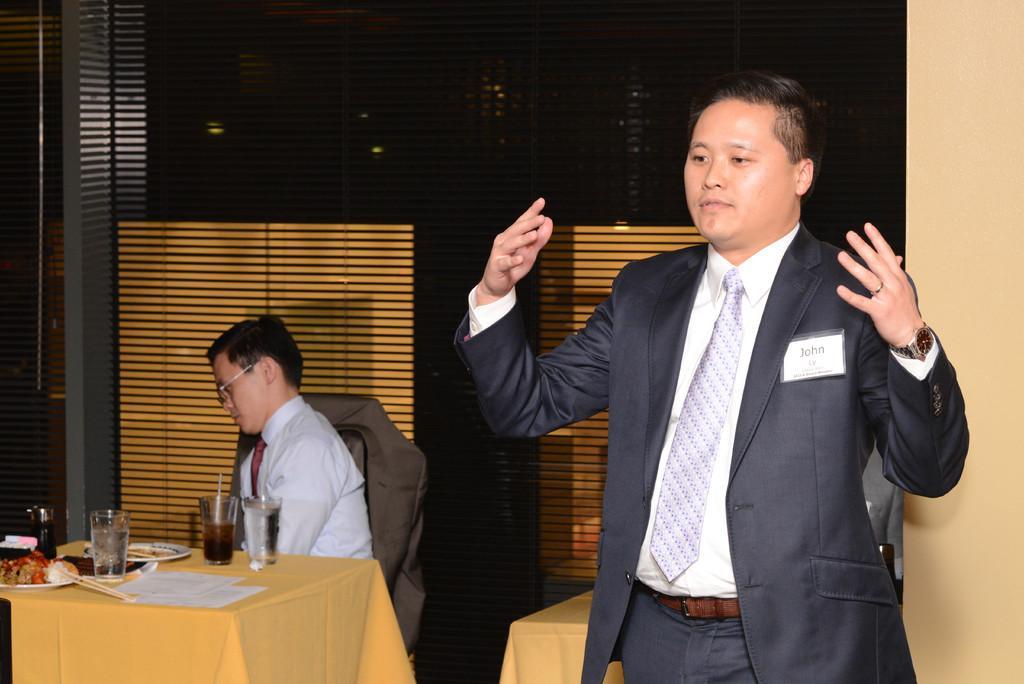Describe this image in one or two sentences. This picture is clicked inside hotel. On the right corner of this picture, we see a man wearing blue blazer and white shirt with white tie, he is carrying a badge and a blazer, with name John written on it. He is even wearing a watch, he is try I think he is trying to talk something and to the back of him, we see in white shirt is wearing glasses, is sitting on a chair and in front of him, we see a table on which glass, plate, food and papers are placed on it. Behind him, we see a wall to wall, glass in yellow and brown color. 